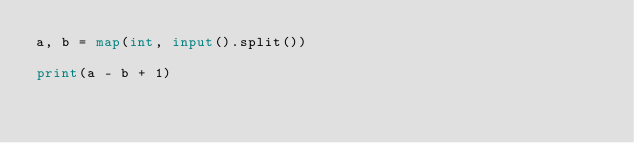Convert code to text. <code><loc_0><loc_0><loc_500><loc_500><_Python_>a, b = map(int, input().split())

print(a - b + 1)</code> 